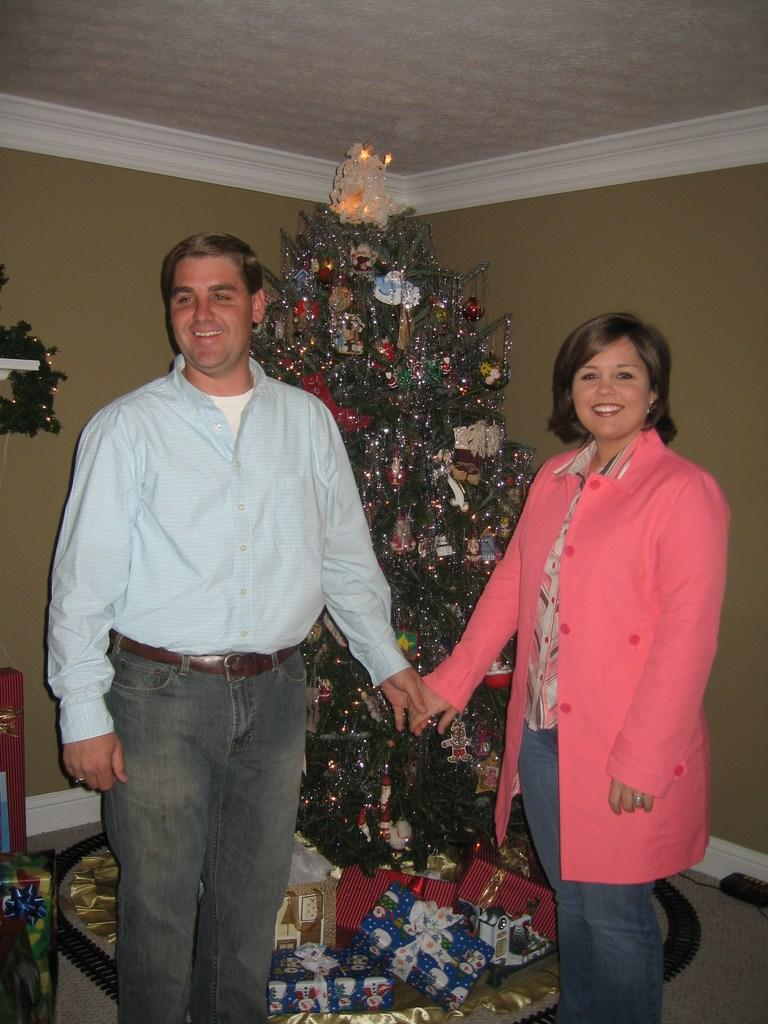What can be seen on the left side of the image? There is a man on the left side of the image. What can be seen on the right side of the image? There is a woman on the right side of the image. What is in the background of the image? There is a tree in the background of the image. How is the tree decorated? The tree is decorated with lights. What type of smell can be detected in the image? There is no information about smells in the image, so it cannot be determined from the image. 